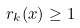<formula> <loc_0><loc_0><loc_500><loc_500>r _ { k } ( x ) \geq 1</formula> 